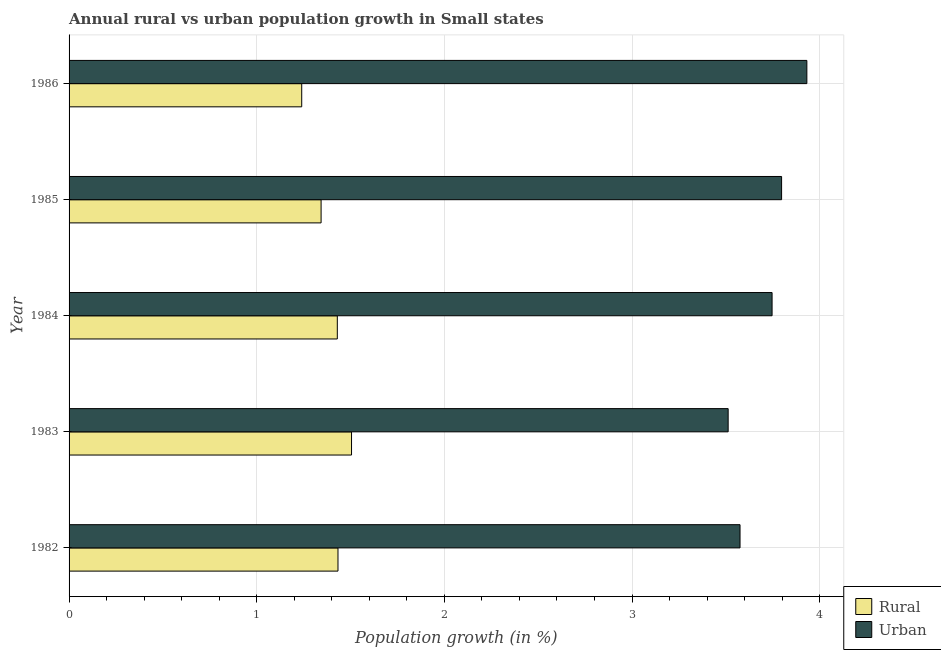How many groups of bars are there?
Provide a succinct answer. 5. Are the number of bars per tick equal to the number of legend labels?
Provide a succinct answer. Yes. How many bars are there on the 3rd tick from the top?
Offer a terse response. 2. What is the label of the 2nd group of bars from the top?
Your response must be concise. 1985. What is the rural population growth in 1984?
Your answer should be compact. 1.43. Across all years, what is the maximum rural population growth?
Offer a terse response. 1.51. Across all years, what is the minimum rural population growth?
Offer a terse response. 1.24. In which year was the rural population growth maximum?
Ensure brevity in your answer.  1983. What is the total urban population growth in the graph?
Keep it short and to the point. 18.56. What is the difference between the urban population growth in 1985 and that in 1986?
Provide a short and direct response. -0.14. What is the difference between the urban population growth in 1984 and the rural population growth in 1985?
Ensure brevity in your answer.  2.4. What is the average rural population growth per year?
Your answer should be very brief. 1.39. In the year 1985, what is the difference between the rural population growth and urban population growth?
Keep it short and to the point. -2.45. What is the ratio of the urban population growth in 1982 to that in 1983?
Your response must be concise. 1.02. Is the urban population growth in 1982 less than that in 1986?
Your response must be concise. Yes. What is the difference between the highest and the second highest urban population growth?
Keep it short and to the point. 0.14. What is the difference between the highest and the lowest rural population growth?
Offer a very short reply. 0.27. What does the 2nd bar from the top in 1982 represents?
Offer a terse response. Rural. What does the 1st bar from the bottom in 1982 represents?
Offer a terse response. Rural. What is the difference between two consecutive major ticks on the X-axis?
Your response must be concise. 1. Are the values on the major ticks of X-axis written in scientific E-notation?
Offer a very short reply. No. Does the graph contain any zero values?
Offer a terse response. No. How many legend labels are there?
Offer a very short reply. 2. How are the legend labels stacked?
Keep it short and to the point. Vertical. What is the title of the graph?
Ensure brevity in your answer.  Annual rural vs urban population growth in Small states. Does "Canada" appear as one of the legend labels in the graph?
Provide a short and direct response. No. What is the label or title of the X-axis?
Give a very brief answer. Population growth (in %). What is the Population growth (in %) of Rural in 1982?
Keep it short and to the point. 1.43. What is the Population growth (in %) of Urban  in 1982?
Provide a short and direct response. 3.58. What is the Population growth (in %) of Rural in 1983?
Your response must be concise. 1.51. What is the Population growth (in %) of Urban  in 1983?
Make the answer very short. 3.51. What is the Population growth (in %) of Rural in 1984?
Ensure brevity in your answer.  1.43. What is the Population growth (in %) of Urban  in 1984?
Make the answer very short. 3.75. What is the Population growth (in %) in Rural in 1985?
Give a very brief answer. 1.34. What is the Population growth (in %) in Urban  in 1985?
Your answer should be compact. 3.8. What is the Population growth (in %) in Rural in 1986?
Your answer should be compact. 1.24. What is the Population growth (in %) in Urban  in 1986?
Your response must be concise. 3.93. Across all years, what is the maximum Population growth (in %) of Rural?
Ensure brevity in your answer.  1.51. Across all years, what is the maximum Population growth (in %) in Urban ?
Give a very brief answer. 3.93. Across all years, what is the minimum Population growth (in %) of Rural?
Ensure brevity in your answer.  1.24. Across all years, what is the minimum Population growth (in %) in Urban ?
Provide a short and direct response. 3.51. What is the total Population growth (in %) of Rural in the graph?
Your response must be concise. 6.95. What is the total Population growth (in %) of Urban  in the graph?
Your response must be concise. 18.56. What is the difference between the Population growth (in %) of Rural in 1982 and that in 1983?
Your answer should be very brief. -0.07. What is the difference between the Population growth (in %) of Urban  in 1982 and that in 1983?
Ensure brevity in your answer.  0.06. What is the difference between the Population growth (in %) in Rural in 1982 and that in 1984?
Provide a short and direct response. 0. What is the difference between the Population growth (in %) in Urban  in 1982 and that in 1984?
Your answer should be very brief. -0.17. What is the difference between the Population growth (in %) in Rural in 1982 and that in 1985?
Offer a terse response. 0.09. What is the difference between the Population growth (in %) in Urban  in 1982 and that in 1985?
Your response must be concise. -0.22. What is the difference between the Population growth (in %) of Rural in 1982 and that in 1986?
Your answer should be compact. 0.19. What is the difference between the Population growth (in %) of Urban  in 1982 and that in 1986?
Offer a very short reply. -0.36. What is the difference between the Population growth (in %) in Rural in 1983 and that in 1984?
Provide a succinct answer. 0.08. What is the difference between the Population growth (in %) in Urban  in 1983 and that in 1984?
Your answer should be compact. -0.23. What is the difference between the Population growth (in %) of Rural in 1983 and that in 1985?
Your answer should be very brief. 0.16. What is the difference between the Population growth (in %) in Urban  in 1983 and that in 1985?
Ensure brevity in your answer.  -0.28. What is the difference between the Population growth (in %) of Rural in 1983 and that in 1986?
Provide a short and direct response. 0.27. What is the difference between the Population growth (in %) in Urban  in 1983 and that in 1986?
Give a very brief answer. -0.42. What is the difference between the Population growth (in %) of Rural in 1984 and that in 1985?
Offer a terse response. 0.09. What is the difference between the Population growth (in %) of Urban  in 1984 and that in 1985?
Provide a succinct answer. -0.05. What is the difference between the Population growth (in %) in Rural in 1984 and that in 1986?
Offer a terse response. 0.19. What is the difference between the Population growth (in %) of Urban  in 1984 and that in 1986?
Offer a terse response. -0.19. What is the difference between the Population growth (in %) in Rural in 1985 and that in 1986?
Your answer should be compact. 0.1. What is the difference between the Population growth (in %) in Urban  in 1985 and that in 1986?
Ensure brevity in your answer.  -0.13. What is the difference between the Population growth (in %) in Rural in 1982 and the Population growth (in %) in Urban  in 1983?
Ensure brevity in your answer.  -2.08. What is the difference between the Population growth (in %) of Rural in 1982 and the Population growth (in %) of Urban  in 1984?
Offer a very short reply. -2.31. What is the difference between the Population growth (in %) of Rural in 1982 and the Population growth (in %) of Urban  in 1985?
Offer a very short reply. -2.36. What is the difference between the Population growth (in %) of Rural in 1982 and the Population growth (in %) of Urban  in 1986?
Keep it short and to the point. -2.5. What is the difference between the Population growth (in %) in Rural in 1983 and the Population growth (in %) in Urban  in 1984?
Keep it short and to the point. -2.24. What is the difference between the Population growth (in %) of Rural in 1983 and the Population growth (in %) of Urban  in 1985?
Your response must be concise. -2.29. What is the difference between the Population growth (in %) in Rural in 1983 and the Population growth (in %) in Urban  in 1986?
Make the answer very short. -2.43. What is the difference between the Population growth (in %) in Rural in 1984 and the Population growth (in %) in Urban  in 1985?
Ensure brevity in your answer.  -2.37. What is the difference between the Population growth (in %) of Rural in 1984 and the Population growth (in %) of Urban  in 1986?
Give a very brief answer. -2.5. What is the difference between the Population growth (in %) in Rural in 1985 and the Population growth (in %) in Urban  in 1986?
Offer a very short reply. -2.59. What is the average Population growth (in %) in Rural per year?
Make the answer very short. 1.39. What is the average Population growth (in %) of Urban  per year?
Provide a succinct answer. 3.71. In the year 1982, what is the difference between the Population growth (in %) in Rural and Population growth (in %) in Urban ?
Your answer should be compact. -2.14. In the year 1983, what is the difference between the Population growth (in %) of Rural and Population growth (in %) of Urban ?
Your answer should be compact. -2.01. In the year 1984, what is the difference between the Population growth (in %) in Rural and Population growth (in %) in Urban ?
Provide a short and direct response. -2.32. In the year 1985, what is the difference between the Population growth (in %) of Rural and Population growth (in %) of Urban ?
Offer a very short reply. -2.45. In the year 1986, what is the difference between the Population growth (in %) in Rural and Population growth (in %) in Urban ?
Offer a terse response. -2.69. What is the ratio of the Population growth (in %) of Rural in 1982 to that in 1983?
Give a very brief answer. 0.95. What is the ratio of the Population growth (in %) in Urban  in 1982 to that in 1983?
Make the answer very short. 1.02. What is the ratio of the Population growth (in %) of Urban  in 1982 to that in 1984?
Make the answer very short. 0.95. What is the ratio of the Population growth (in %) in Rural in 1982 to that in 1985?
Ensure brevity in your answer.  1.07. What is the ratio of the Population growth (in %) in Urban  in 1982 to that in 1985?
Keep it short and to the point. 0.94. What is the ratio of the Population growth (in %) in Rural in 1982 to that in 1986?
Give a very brief answer. 1.16. What is the ratio of the Population growth (in %) in Urban  in 1982 to that in 1986?
Your answer should be very brief. 0.91. What is the ratio of the Population growth (in %) in Rural in 1983 to that in 1984?
Provide a succinct answer. 1.05. What is the ratio of the Population growth (in %) in Rural in 1983 to that in 1985?
Provide a short and direct response. 1.12. What is the ratio of the Population growth (in %) of Urban  in 1983 to that in 1985?
Provide a short and direct response. 0.93. What is the ratio of the Population growth (in %) of Rural in 1983 to that in 1986?
Your answer should be very brief. 1.21. What is the ratio of the Population growth (in %) of Urban  in 1983 to that in 1986?
Provide a short and direct response. 0.89. What is the ratio of the Population growth (in %) of Rural in 1984 to that in 1985?
Your response must be concise. 1.06. What is the ratio of the Population growth (in %) of Urban  in 1984 to that in 1985?
Offer a terse response. 0.99. What is the ratio of the Population growth (in %) in Rural in 1984 to that in 1986?
Provide a succinct answer. 1.15. What is the ratio of the Population growth (in %) in Urban  in 1984 to that in 1986?
Your response must be concise. 0.95. What is the ratio of the Population growth (in %) in Rural in 1985 to that in 1986?
Provide a succinct answer. 1.08. What is the ratio of the Population growth (in %) of Urban  in 1985 to that in 1986?
Your response must be concise. 0.97. What is the difference between the highest and the second highest Population growth (in %) of Rural?
Offer a terse response. 0.07. What is the difference between the highest and the second highest Population growth (in %) of Urban ?
Ensure brevity in your answer.  0.13. What is the difference between the highest and the lowest Population growth (in %) of Rural?
Ensure brevity in your answer.  0.27. What is the difference between the highest and the lowest Population growth (in %) of Urban ?
Provide a succinct answer. 0.42. 